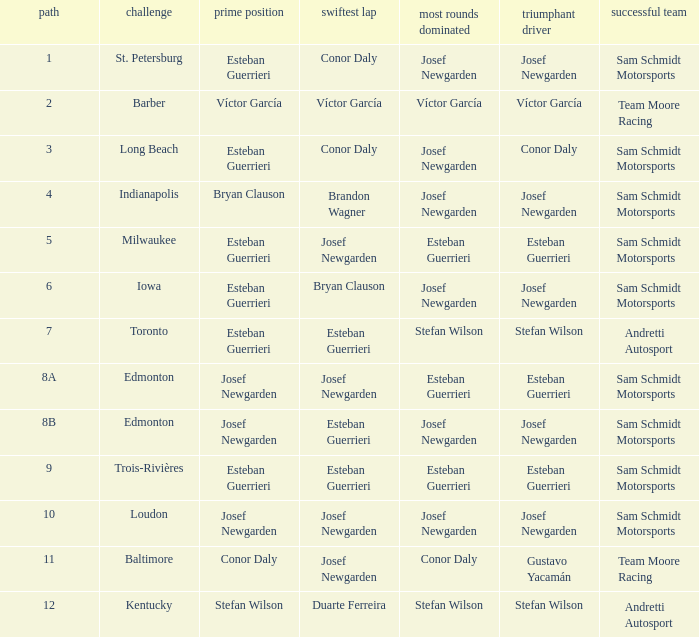Who had the fastest lap(s) when stefan wilson had the pole? Duarte Ferreira. 